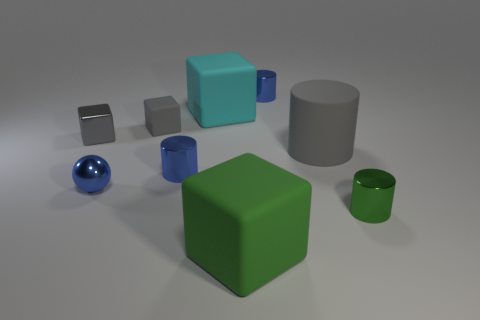How does the texture of the green cube compare to that of the blue spheres? The texture of the green cube is matte and less reflective, whereas the blue spheres have a shiny, reflective surface which catches the light differently. 